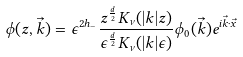<formula> <loc_0><loc_0><loc_500><loc_500>\phi ( z , \vec { k } ) = \epsilon ^ { 2 h _ { - } } \frac { z ^ { \frac { d } { 2 } } K _ { \nu } ( | k | z ) } { \epsilon ^ { \frac { d } { 2 } } K _ { \nu } ( | k | \epsilon ) } \phi _ { 0 } ( \vec { k } ) e ^ { i \vec { k } \cdot \vec { x } }</formula> 